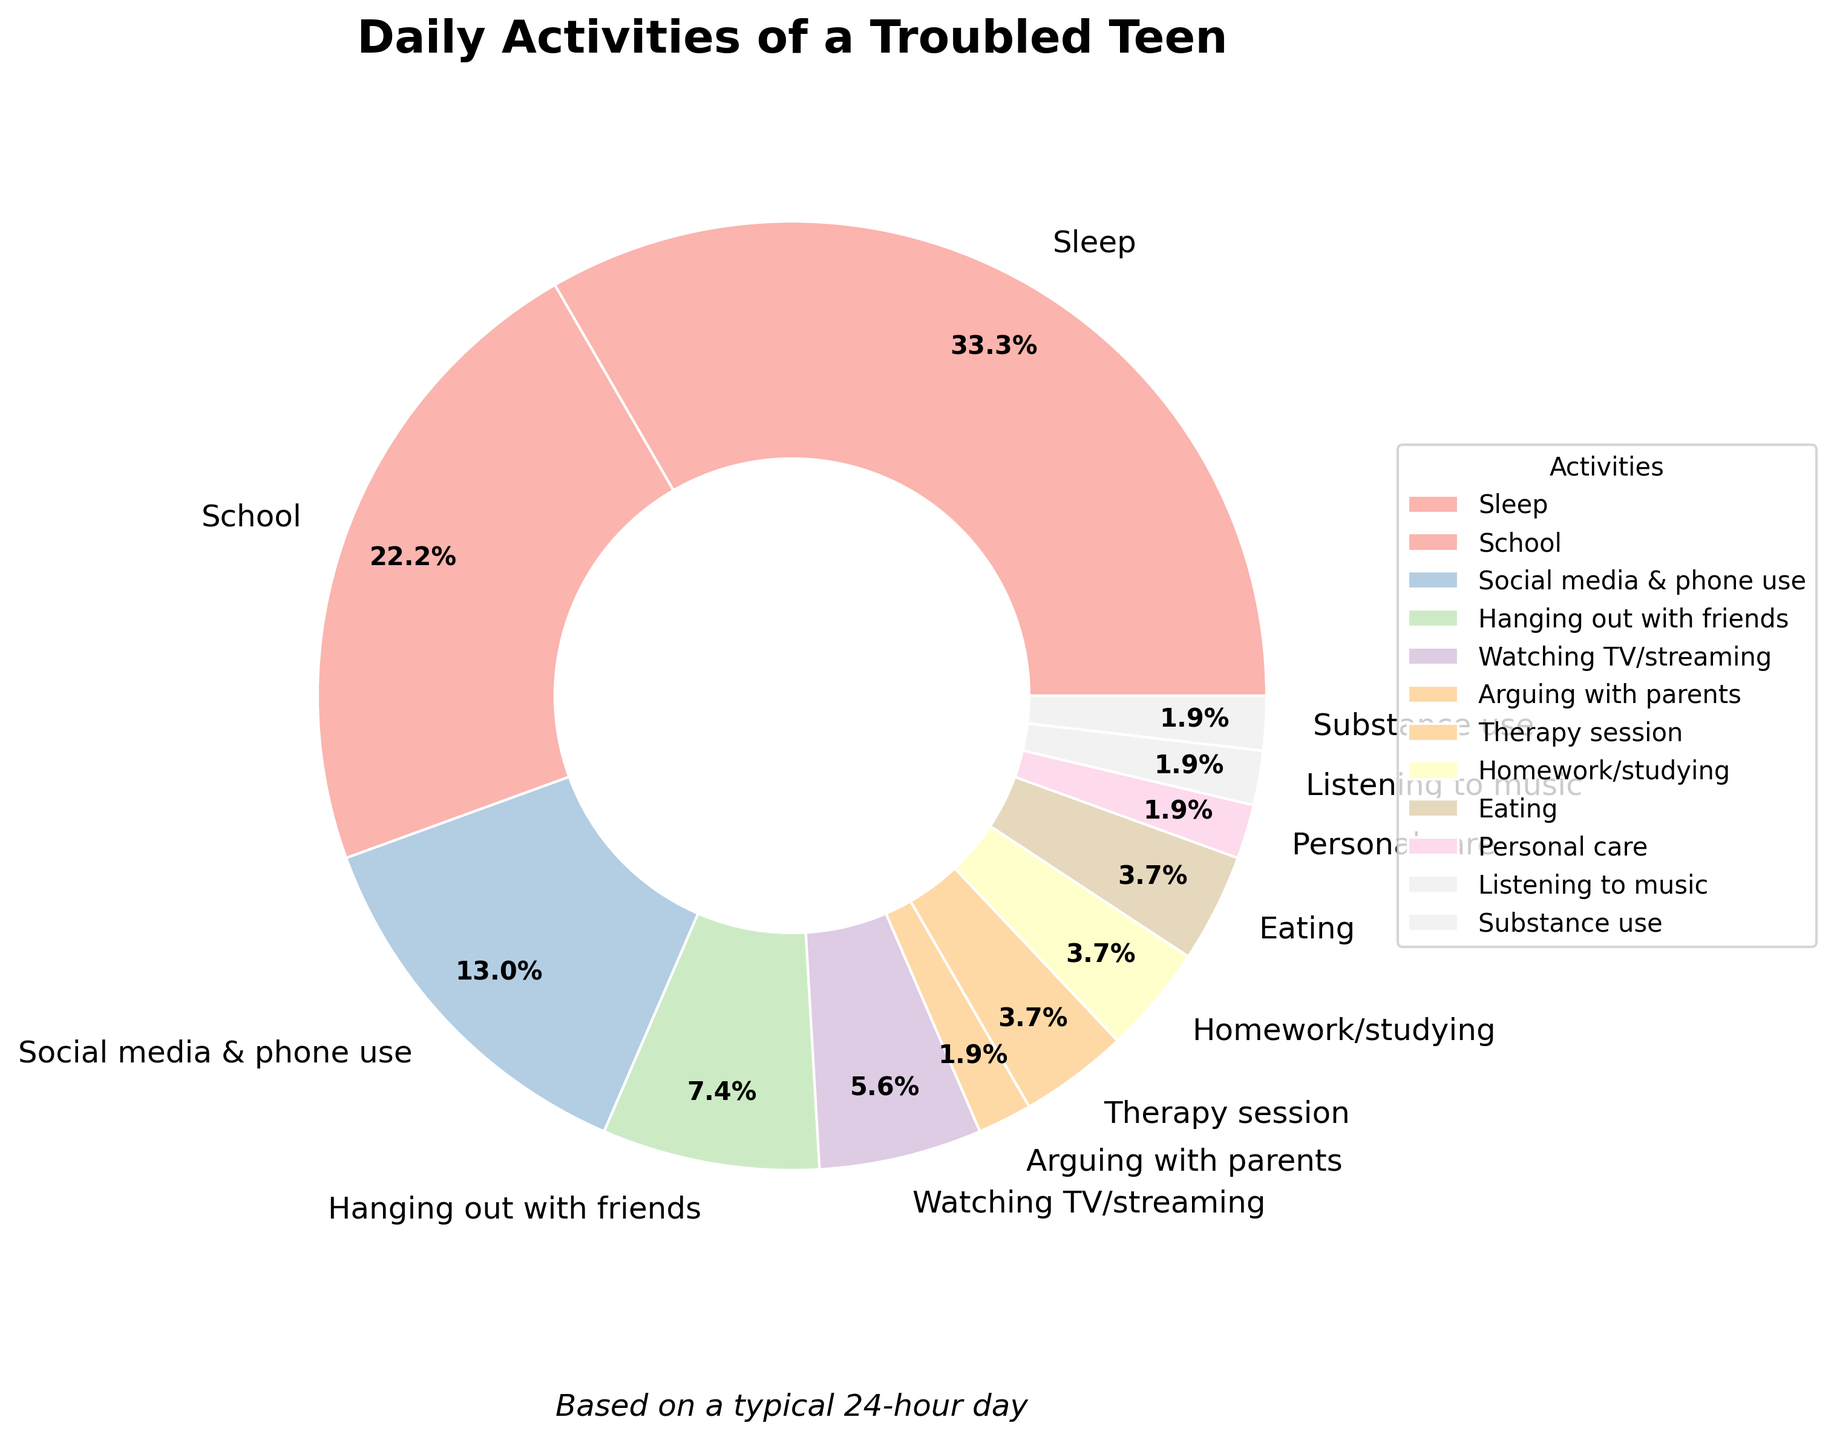What's the total amount of time spent on personal care and eating combined? To find the total time for personal care and eating, add the hours for both activities. Personal care is 0.5 hours and eating is 1 hour. Therefore, 0.5 + 1 = 1.5 hours.
Answer: 1.5 hours Which activity takes up more time: Social media & phone use or Therapy session? Compare the hours for Social media & phone use and Therapy session. Social media & phone use is 3.5 hours, while Therapy session is 1 hour. Since 3.5 > 1, Social media & phone use takes up more time.
Answer: Social media & phone use What is the ratio of time spent on hanging out with friends to watching TV/streaming? To find the ratio, compare the hours for hanging out with friends and watching TV/streaming. Hanging out with friends is 2 hours, and watching TV/streaming is 1.5 hours. Therefore, the ratio is 2:1.5, which simplifies to 4:3.
Answer: 4:3 What percentage of the day is spent at school? The total hours in a day are 24. Time spent at school is 6 hours. To find the percentage, divide 6 by 24 and multiply by 100. Thus, (6 / 24) * 100 = 25%.
Answer: 25% How much more time is spent sleeping compared to doing homework/studying? To find out how much more time is spent sleeping, subtract the hours spent on homework/studying from the hours spent sleeping. Sleep is 9 hours and homework/studying is 1 hour. Therefore, 9 - 1 = 8 hours.
Answer: 8 hours What is the combined percentage of time spent arguing with parents, in therapy session, and substance use? To find the combined percentage, sum the hours for arguing with parents, therapy session, and substance use, then divide by 24 and multiply by 100. These activities are 0.5, 1, and 0.5 hours respectively, so 0.5 + 1 + 0.5 = 2 hours. Therefore, (2 / 24) * 100 = 8.3%.
Answer: 8.3% Which activity represents the smallest proportion of the day? Identify which activity has the smallest number of hours. Both arguing with parents, personal care, listening to music, and substance use are 0.5 hours each. Since they all are the smallest amounts, they equally represent the smallest proportion.
Answer: Arguing with parents, Personal care, Listening to music, Substance use Is more time spent hanging out with friends or doing a therapy session? Compare the hours for hanging out with friends and therapy session. Hanging out with friends is 2 hours, and therapy session is 1 hour. Since 2 > 1, more time is spent hanging out with friends.
Answer: Hanging out with friends How does the time spent listening to music compare to time spent eating? Compare the hours for listening to music and eating. Listening to music is 0.5 hours and eating is 1 hour. Since 0.5 < 1, less time is spent listening to music.
Answer: Less time is spent listening to music What is the percentage difference between time spent on social media & phone use and watching TV/streaming? First, find the difference in hours: 3.5 (social media & phone use) - 1.5 (watching TV/streaming) = 2 hours. To find the percentage difference, divide 2 by 24 and multiply by 100. Thus, (2 / 24) * 100 = 8.3%.
Answer: 8.3% 